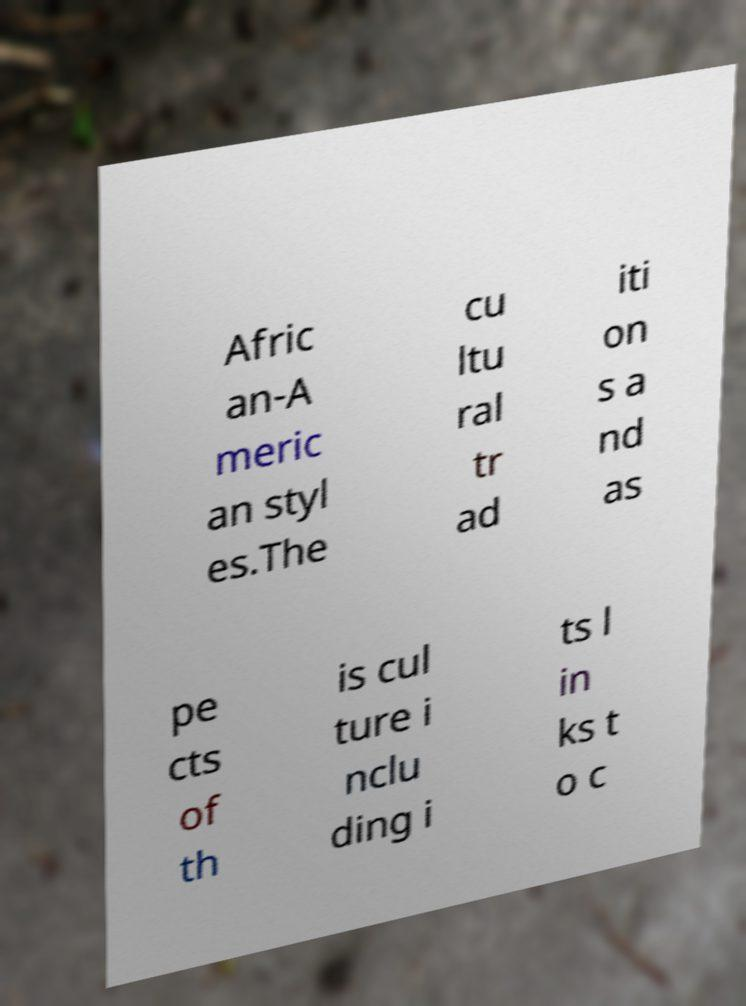Please read and relay the text visible in this image. What does it say? Afric an-A meric an styl es.The cu ltu ral tr ad iti on s a nd as pe cts of th is cul ture i nclu ding i ts l in ks t o c 